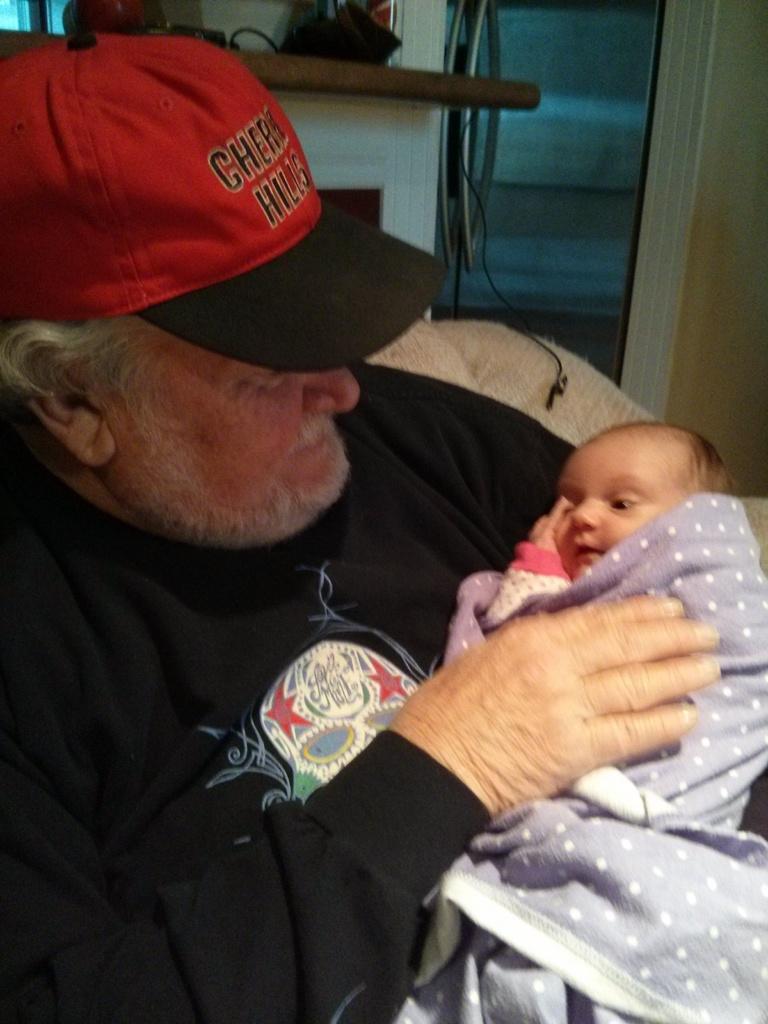What does it say on the hat?
Make the answer very short. Cherry hills. What color are the letters on the hat?
Provide a short and direct response. Black. 